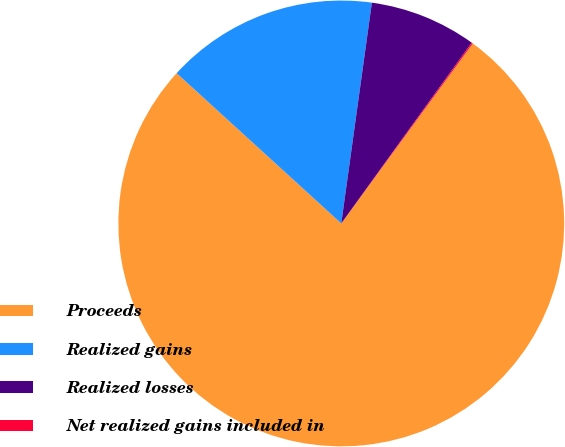<chart> <loc_0><loc_0><loc_500><loc_500><pie_chart><fcel>Proceeds<fcel>Realized gains<fcel>Realized losses<fcel>Net realized gains included in<nl><fcel>76.73%<fcel>15.42%<fcel>7.76%<fcel>0.09%<nl></chart> 